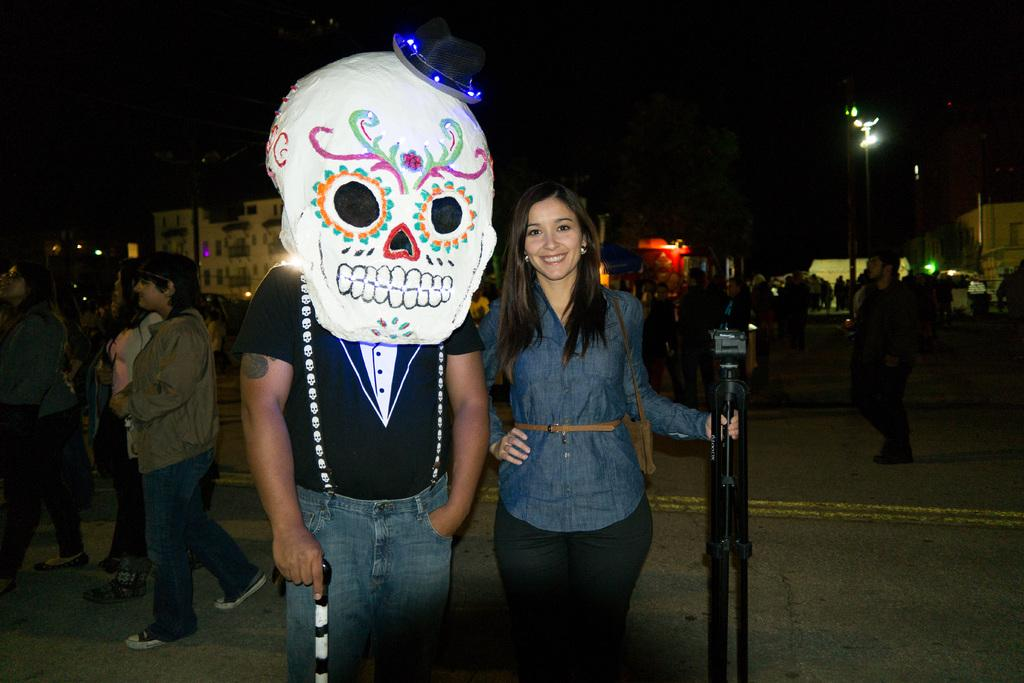What are the people in the image doing? The people in the image are standing and walking. What can be seen in the distance in the image? There are buildings, poles, and lights in the background of the image. What type of celery can be seen growing in the image? There is no celery present in the image. What channel is the pump connected to in the image? There is no pump or channel present in the image. 